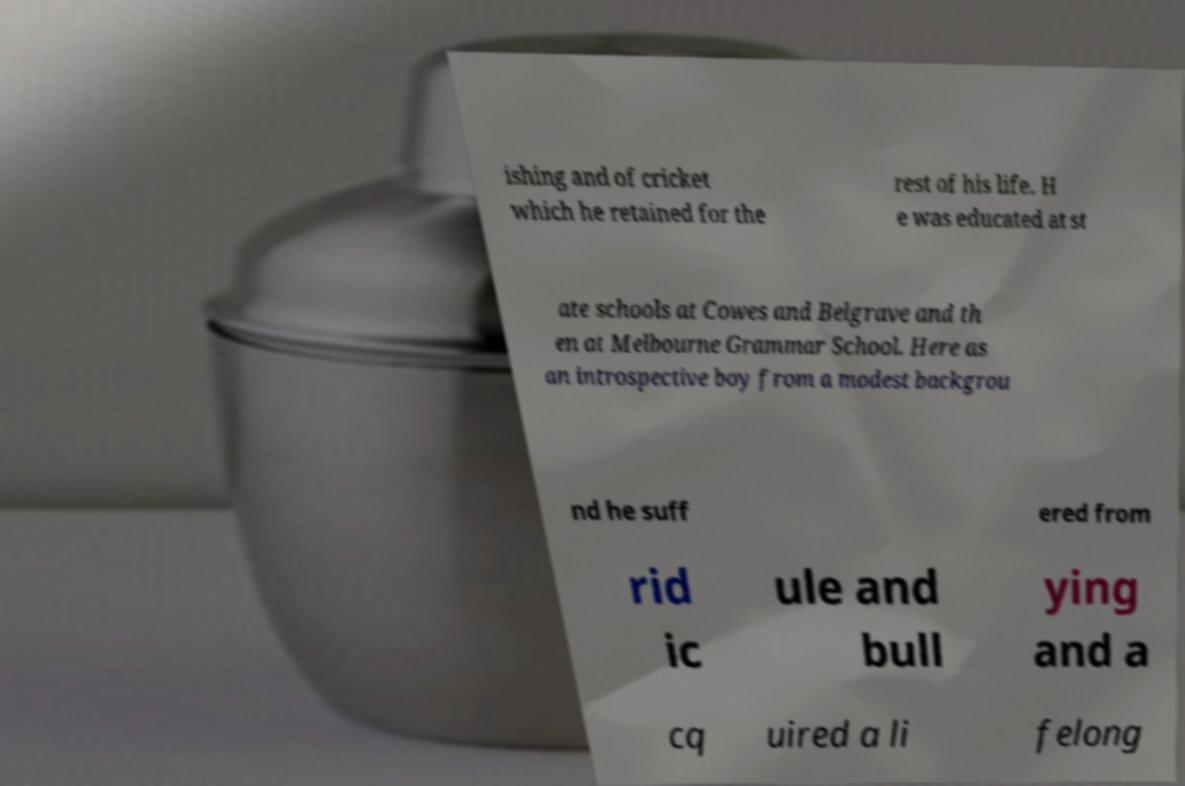Could you assist in decoding the text presented in this image and type it out clearly? ishing and of cricket which he retained for the rest of his life. H e was educated at st ate schools at Cowes and Belgrave and th en at Melbourne Grammar School. Here as an introspective boy from a modest backgrou nd he suff ered from rid ic ule and bull ying and a cq uired a li felong 